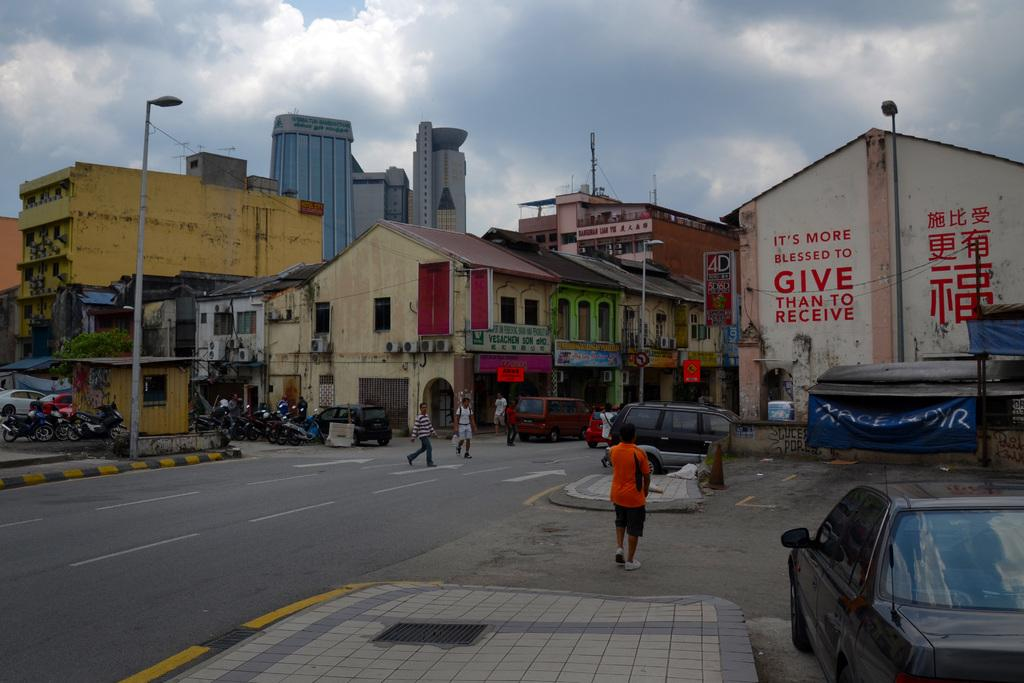What can be seen on the road in the image? There are people and vehicles on the road in the image. What structures are present in the image? There are light poles, posters, and buildings in the image. What type of vegetation is visible in the image? There is a tree in the image. What else can be seen in the image besides the mentioned objects? There are some objects in the image. What is visible in the background of the image? The sky with clouds is visible in the background of the image. Can you tell me how many teeth are visible on the poster in the image? There are no teeth visible on the poster or any other part of the image. What type of railway can be seen in the middle of the image? There is no railway present in the image. 